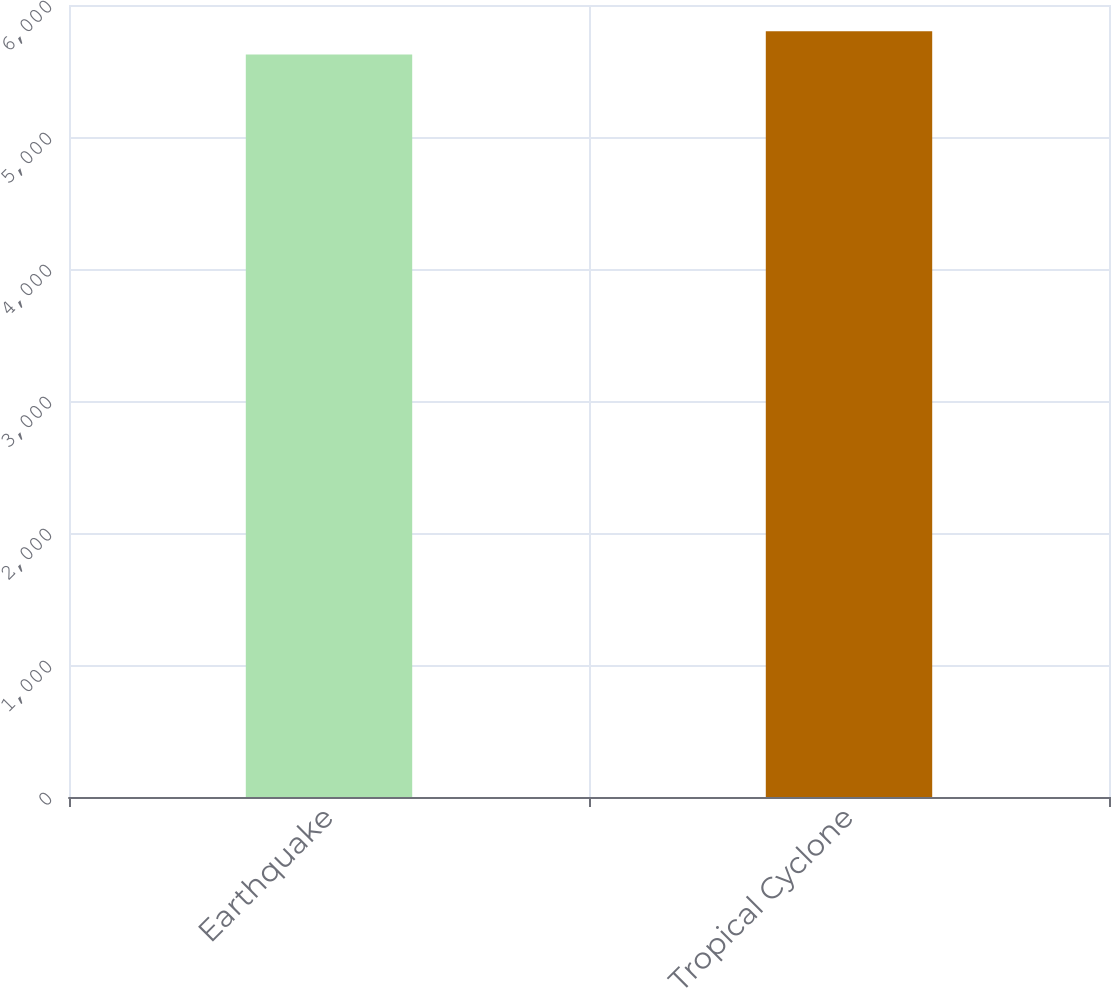<chart> <loc_0><loc_0><loc_500><loc_500><bar_chart><fcel>Earthquake<fcel>Tropical Cyclone<nl><fcel>5625<fcel>5802<nl></chart> 